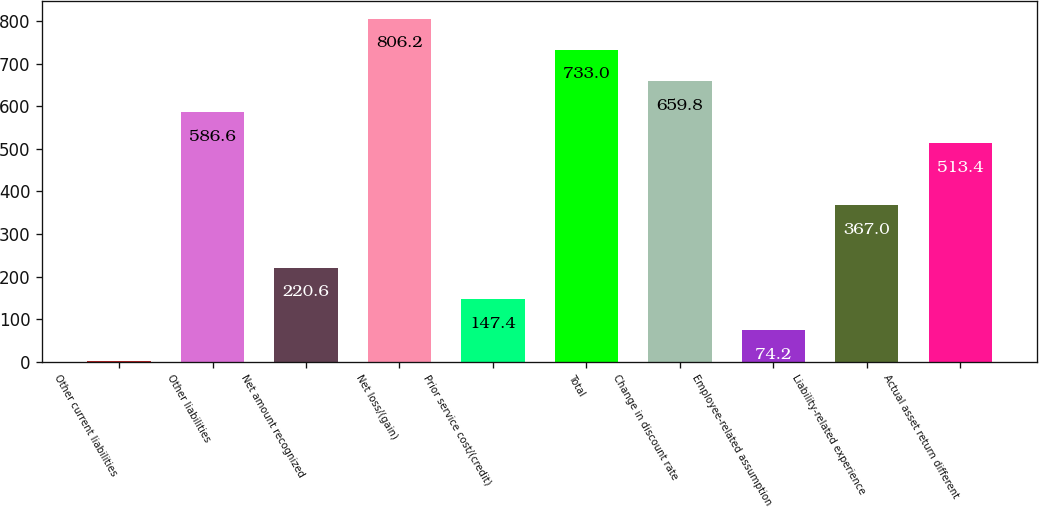Convert chart. <chart><loc_0><loc_0><loc_500><loc_500><bar_chart><fcel>Other current liabilities<fcel>Other liabilities<fcel>Net amount recognized<fcel>Net loss/(gain)<fcel>Prior service cost/(credit)<fcel>Total<fcel>Change in discount rate<fcel>Employee-related assumption<fcel>Liability-related experience<fcel>Actual asset return different<nl><fcel>1<fcel>586.6<fcel>220.6<fcel>806.2<fcel>147.4<fcel>733<fcel>659.8<fcel>74.2<fcel>367<fcel>513.4<nl></chart> 